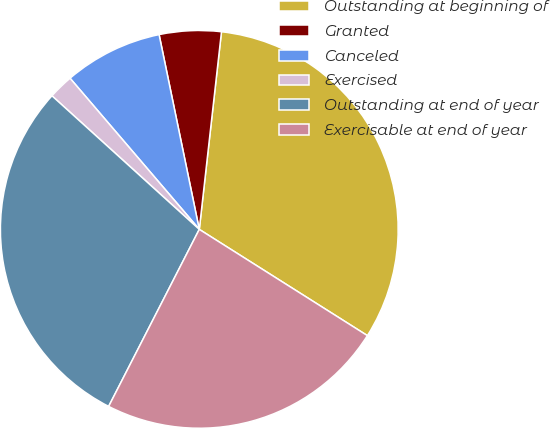<chart> <loc_0><loc_0><loc_500><loc_500><pie_chart><fcel>Outstanding at beginning of<fcel>Granted<fcel>Canceled<fcel>Exercised<fcel>Outstanding at end of year<fcel>Exercisable at end of year<nl><fcel>32.19%<fcel>5.02%<fcel>8.02%<fcel>2.02%<fcel>29.19%<fcel>23.56%<nl></chart> 